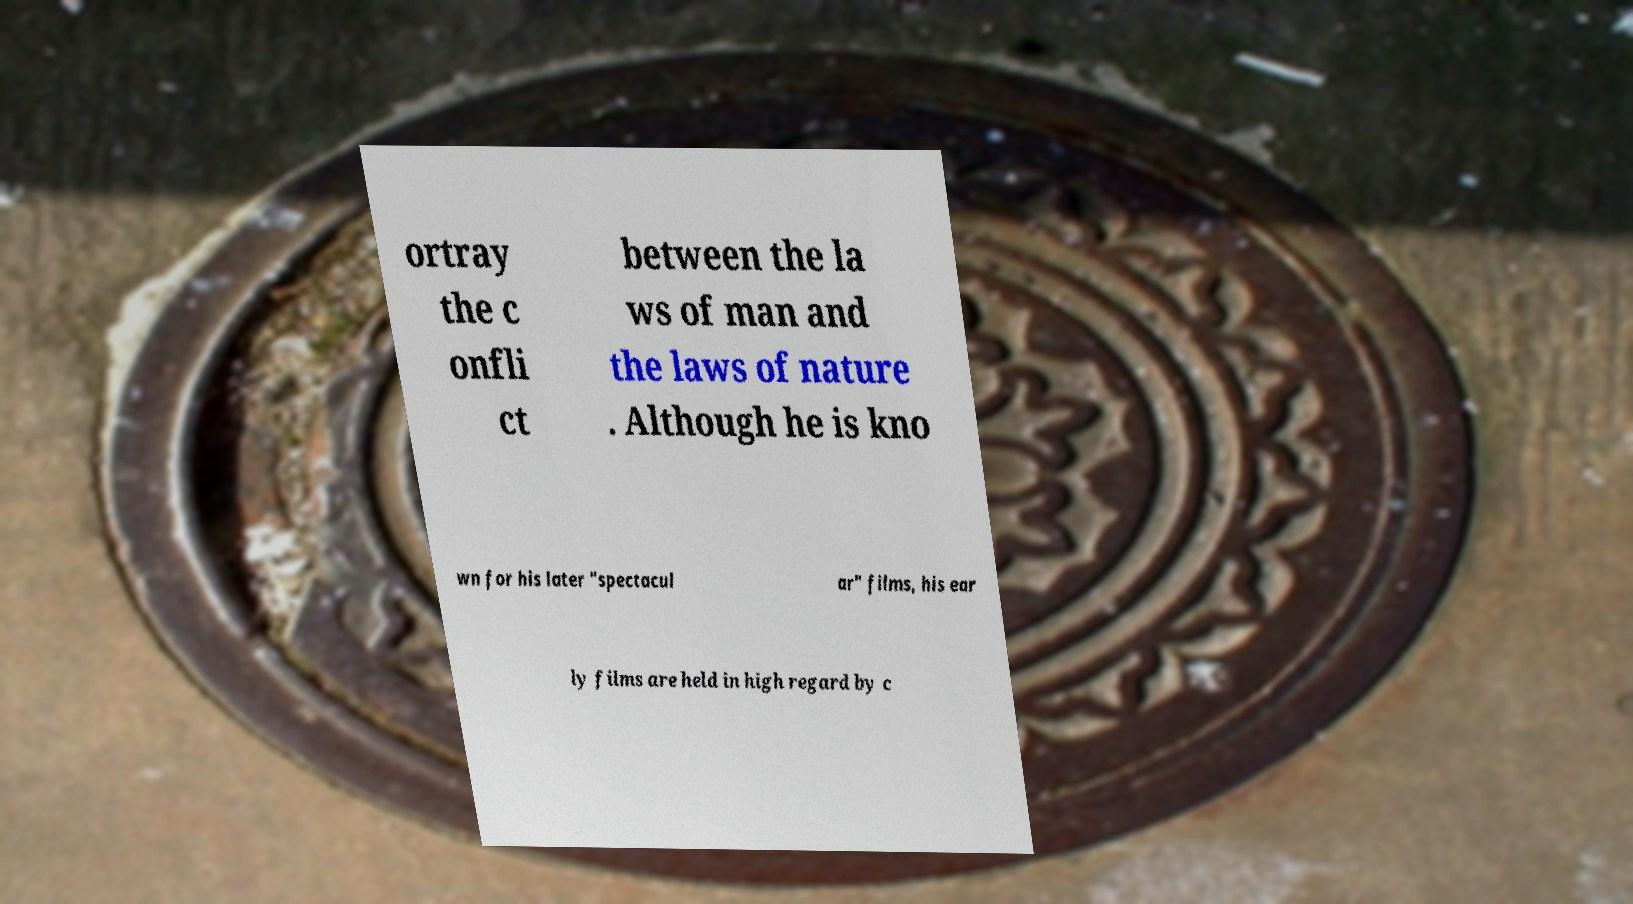Could you extract and type out the text from this image? ortray the c onfli ct between the la ws of man and the laws of nature . Although he is kno wn for his later "spectacul ar" films, his ear ly films are held in high regard by c 